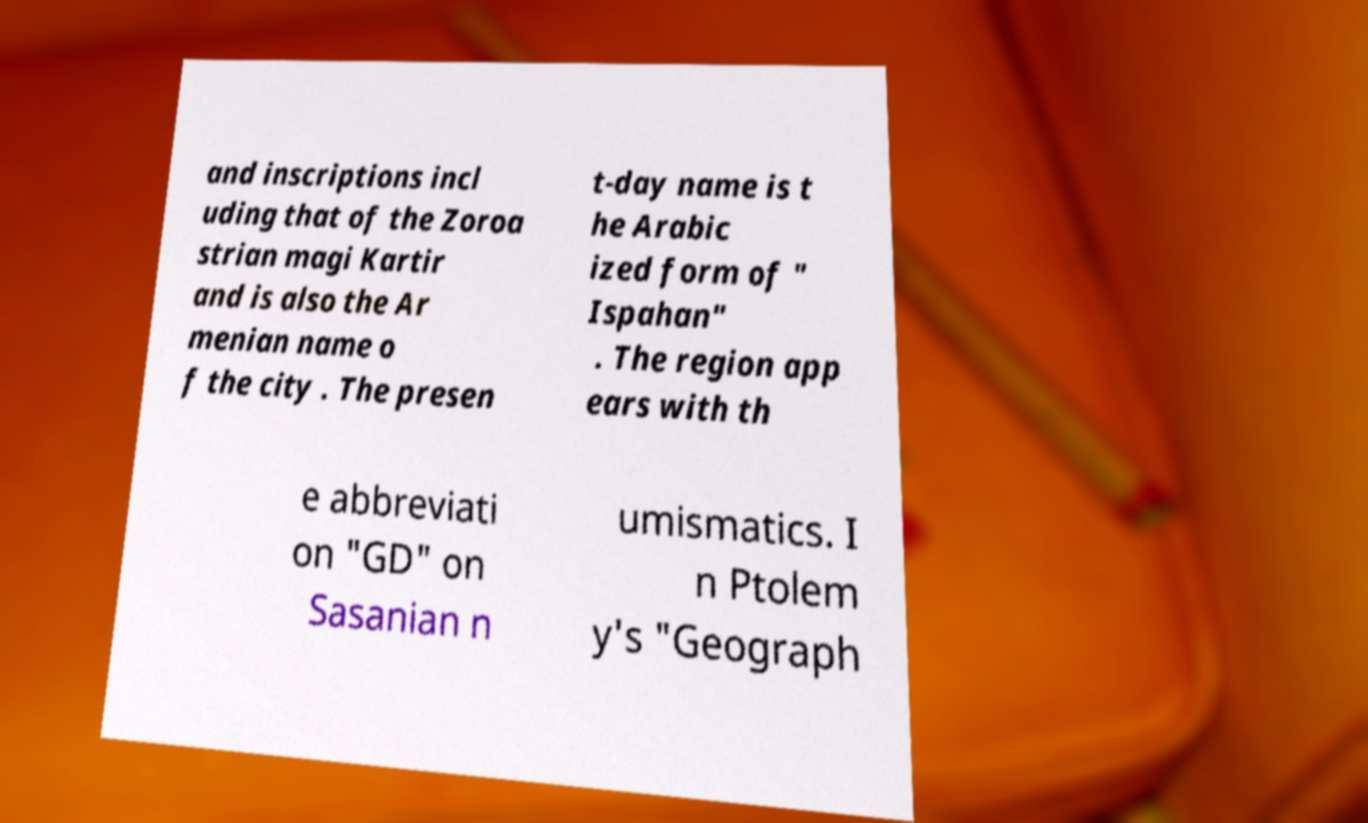I need the written content from this picture converted into text. Can you do that? and inscriptions incl uding that of the Zoroa strian magi Kartir and is also the Ar menian name o f the city . The presen t-day name is t he Arabic ized form of " Ispahan" . The region app ears with th e abbreviati on "GD" on Sasanian n umismatics. I n Ptolem y's "Geograph 